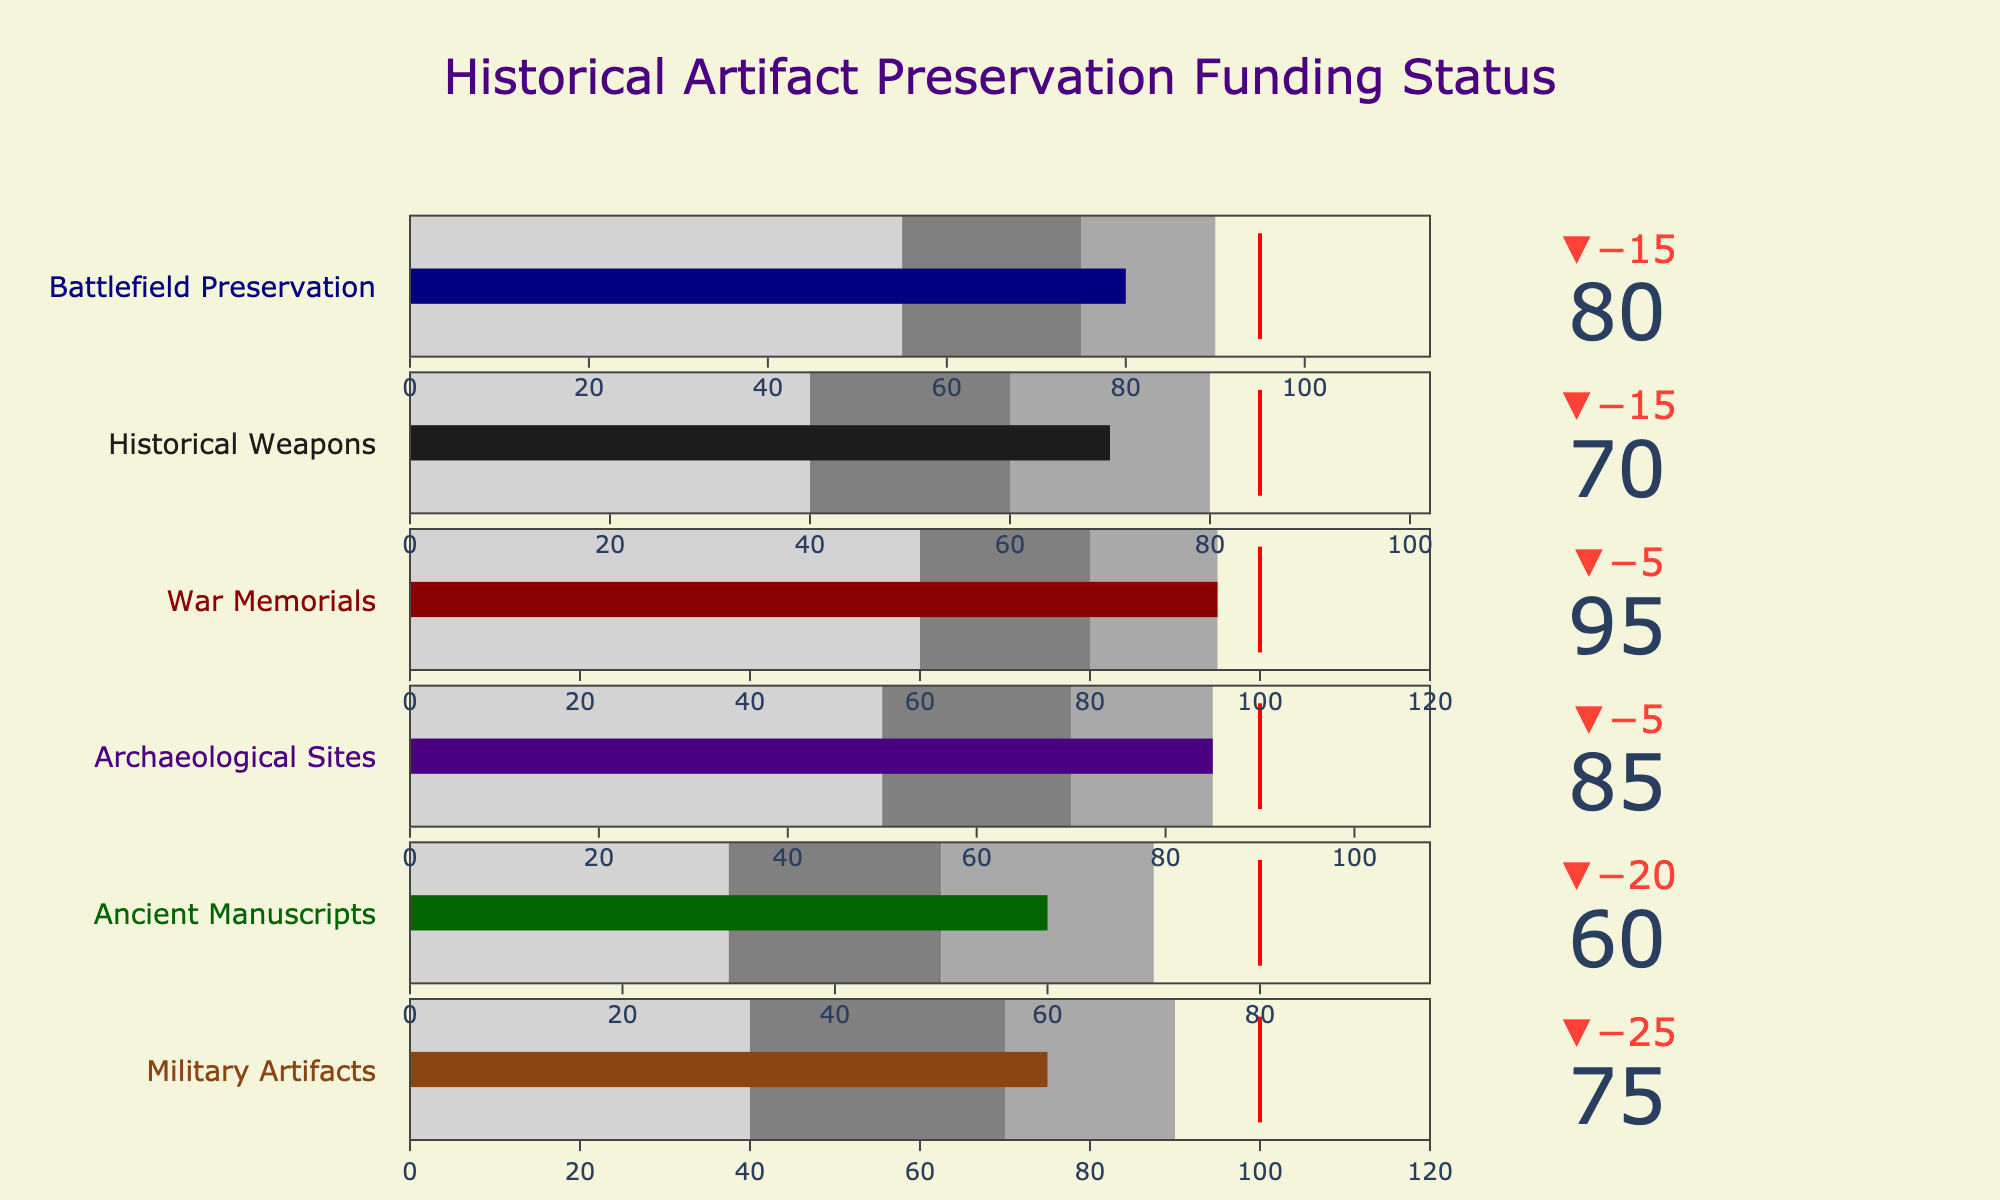What's the title of the chart? The title of a chart is usually located at the top, providing a concise description of what the chart represents. In this case, the title is "Historical Artifact Preservation Funding Status".
Answer: Historical Artifact Preservation Funding Status What is the target value for Military Artifacts preservation funding? The target value for each category is indicated by the red line and specified in the data. The target for Military Artifacts is 100.
Answer: 100 Compare the actual funding for Ancient Manuscripts and War Memorials. Which one is higher and by how much? The actual funding for Ancient Manuscripts is 60, and for War Memorials is 95. To find the difference, subtract 60 from 95, which equals 35. Thus, War Memorials funding is higher by 35.
Answer: War Memorials by 35 Which category has the actual funding closest to its target? To find the category with the actual funding closest to its target, we compare the differences between the actual and target values for all categories. For Military Artifacts (75, 100), the difference is 25. For Ancient Manuscripts (60, 80), it’s 20. For Archaeological Sites (85, 90), it’s 5. For War Memorials (95, 100), it’s 5. For Historical Weapons (70, 85), it’s 15. For Battlefield Preservation (80, 95), it’s 15. Both Archaeological Sites and War Memorials have the smallest difference of 5.
Answer: Archaeological Sites and War Memorials What is the range for the darkest gray area in the Battlefield Preservation category? The darkest gray area represents the third range specified for each category. For Battlefield Preservation, this range is from the second range value to the third range value, which are 75 and 90, respectively. Thus, the darkest gray area covers the range from 75 to 90.
Answer: 75 to 90 Does any category exceed its target funding? If so, which one(s)? To determine if any category exceeds its target funding, we need to compare the actual value with the target value for each category. All actual values are less than or equal to their respective targets. Therefore, no category exceeds its target funding.
Answer: None What is the combined actual funding for Military Artifacts and Historical Weapons? To find the combined actual funding, we add the actual values for Military Artifacts (75) and Historical Weapons (70). This results in a total of 145.
Answer: 145 Which category has the lowest actual funding, and what is that value? The category with the lowest actual funding can be identified by comparing the actual values. Ancient Manuscripts have the lowest actual funding of 60.
Answer: Ancient Manuscripts, 60 